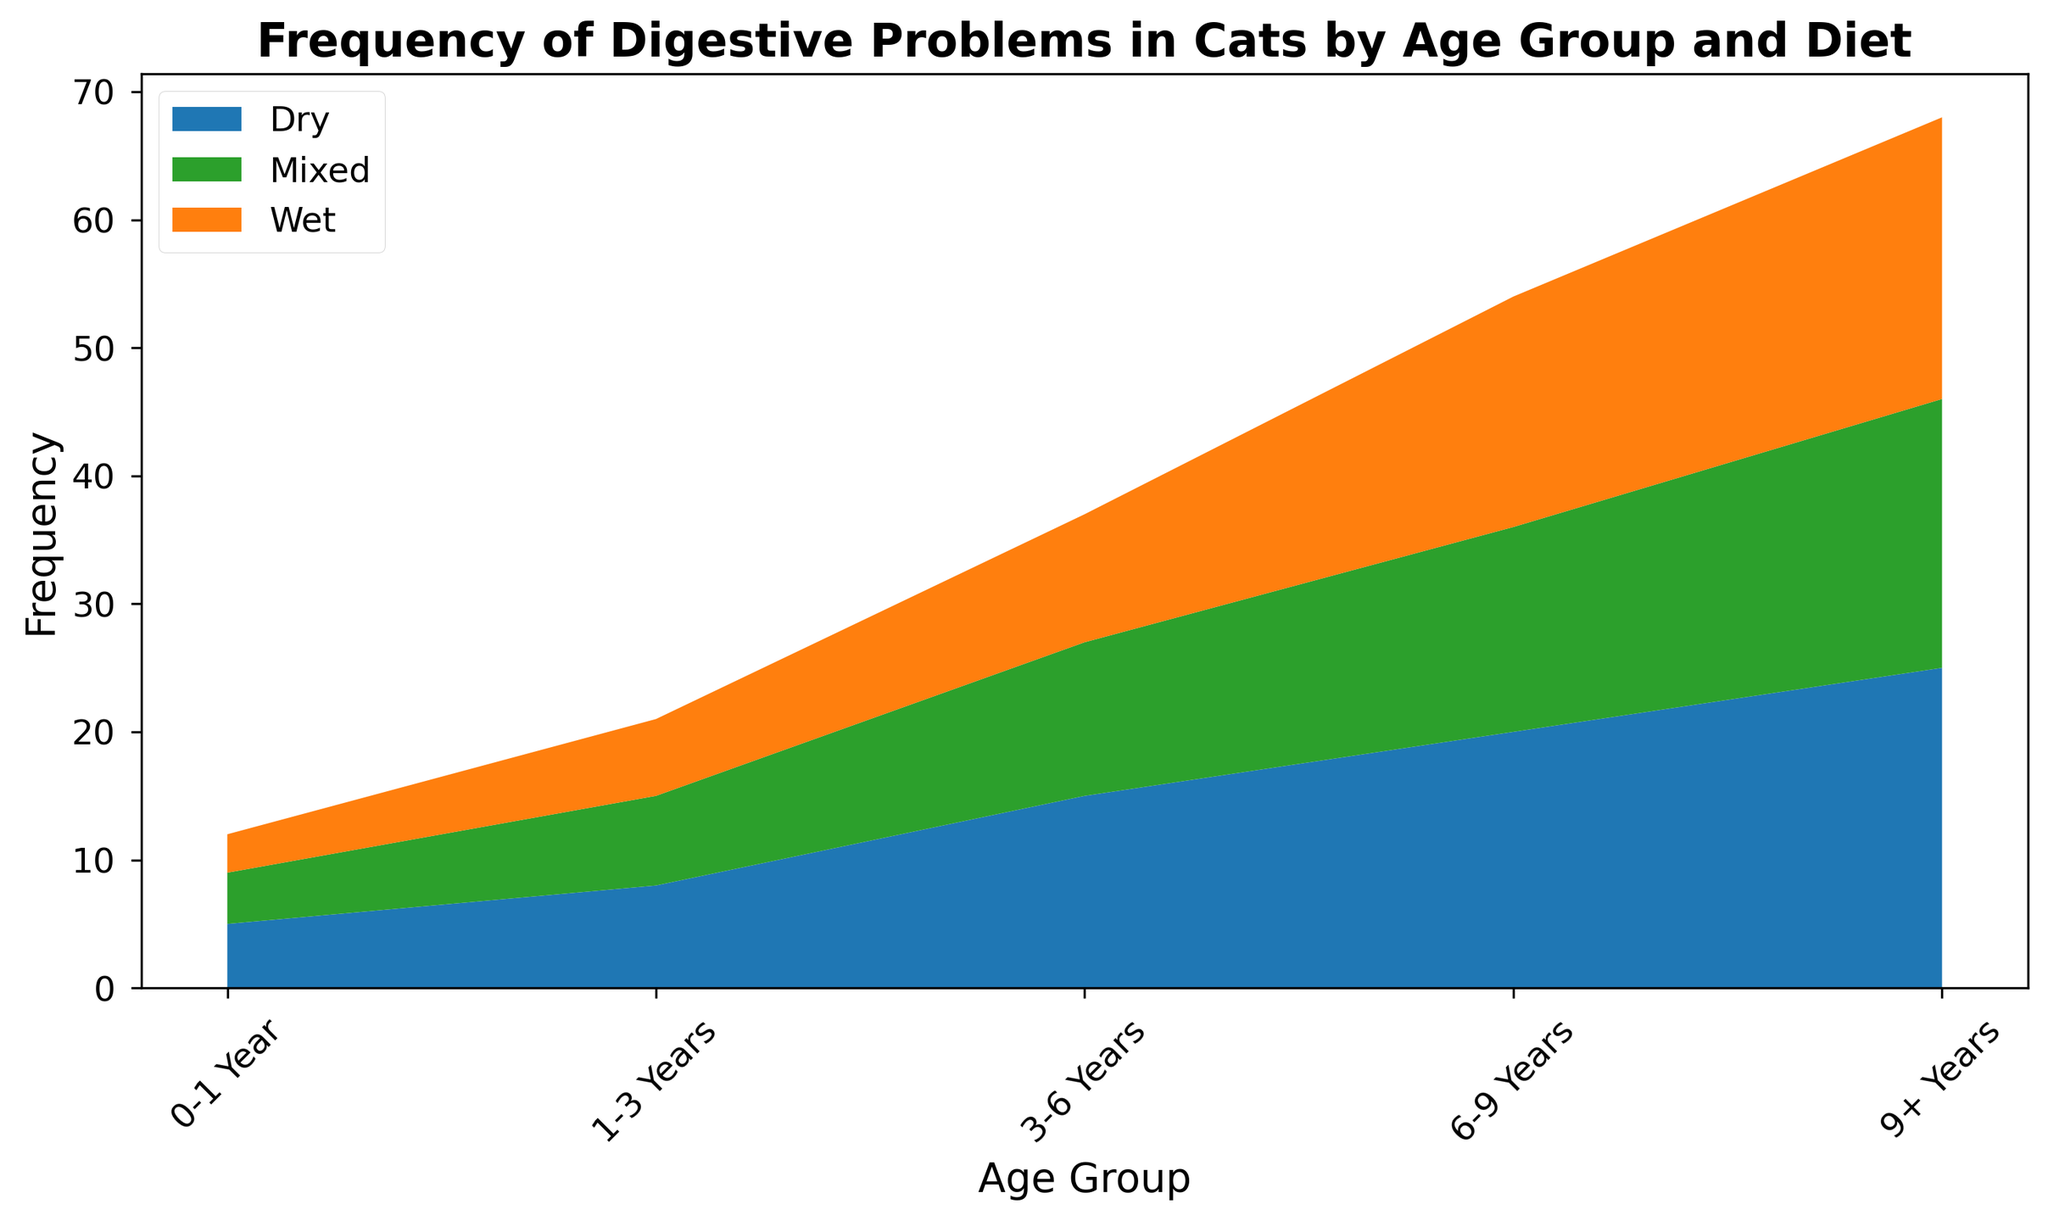What's the total frequency of digestive problems for cats aged 9+ years across all diet types? Sum the frequencies for "9+ Years" across Dry (25), Wet (22), and Mixed (21): 25 + 22 + 21 = 68
Answer: 68 Which diet type corresponds to the highest frequency of digestive problems in cats aged 6-9 years? Compare frequencies for "6-9 Years": Dry (20), Wet (18), and Mixed (16). The highest frequency is Dry with 20
Answer: Dry Do cats under 1 year have a higher frequency of digestive problems on a wet diet or a mixed diet? Compare frequencies for "0-1 Year": Wet (3) and Mixed (4). The mixed diet (4) is higher than the wet diet (3)
Answer: Mixed What is the average frequency of digestive problems for the 3-6 years age group across all diet types? Calculate the average by summing frequencies for "3-6 Years" (Dry: 15, Wet: 10, Mixed: 12) and dividing by the number of diet types (3): (15 + 10 + 12) / 3 = 37 / 3 = 12.33
Answer: 12.33 By how much does the frequency of digestive problems in cats aged 1-3 years with a dry diet exceed that with a wet diet? Subtract the frequency for Wet (6) from Dry (8) for "1-3 Years": 8 - 6 = 2
Answer: 2 For which age group does the wet diet show the highest frequency of digestive problems? Compare Wet diet frequencies across age groups: 0-1 Year (3), 1-3 Years (6), 3-6 Years (10), 6-9 Years (18), 9+ Years (22). The highest frequency is for 9+ Years
Answer: 9+ Years What is the overall trend for digestive problems from the youngest to the oldest age group for cats on a dry diet? Observe the frequency values for Dry across age groups: increase from 0-1 Year (5), 1-3 Years (8), 3-6 Years (15), 6-9 Years (20), and 9+ Years (25). It shows a consistent increase
Answer: Increase What is the frequency difference between dry and mixed diets for cats aged 9+ years? Subtract the frequency for Mixed (21) from Dry (25) for "9+ Years": 25 - 21 = 4
Answer: 4 Do any age groups have the same frequency of digestive problems for both wet and mixed diets? Compare the frequencies of Wet and Mixed diets for all age groups: 0-1 Year (Wet: 3, Mixed: 4), 1-3 Years (Wet: 6, Mixed: 7), 3-6 Years (Wet: 10, Mixed: 12), 6-9 Years (Wet: 18, Mixed: 16), and 9+ Years (Wet: 22, Mixed: 21). None of the age groups have matching frequencies for Wet and Mixed diets
Answer: No What is the visual trend in the height of the stack for the wet diet from the 3-6 years group to the 9+ years group? Observe the height increase in the Wet diet segment: 3-6 Years (10), 6-9 Years (18), and 9+ Years (22). The height increases
Answer: Increases 